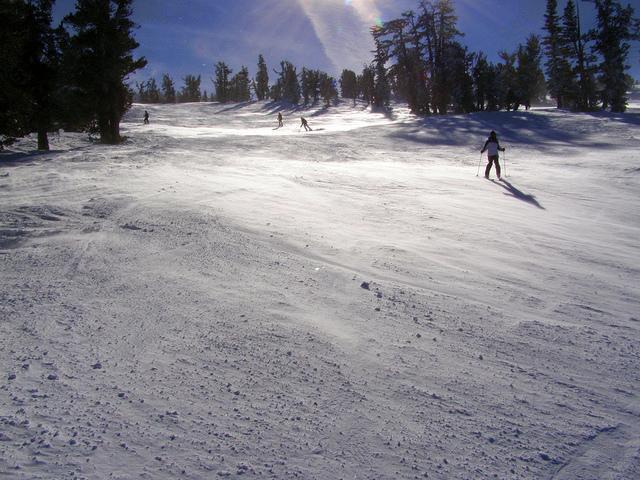How many skiers are in the photo?
Give a very brief answer. 4. How many bears are standing near the waterfalls?
Give a very brief answer. 0. 